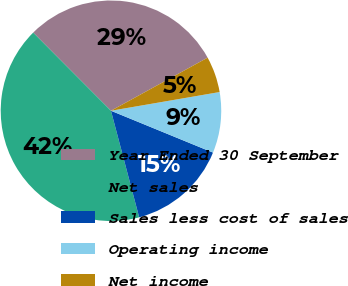Convert chart. <chart><loc_0><loc_0><loc_500><loc_500><pie_chart><fcel>Year Ended 30 September<fcel>Net sales<fcel>Sales less cost of sales<fcel>Operating income<fcel>Net income<nl><fcel>29.47%<fcel>41.66%<fcel>14.69%<fcel>8.91%<fcel>5.28%<nl></chart> 